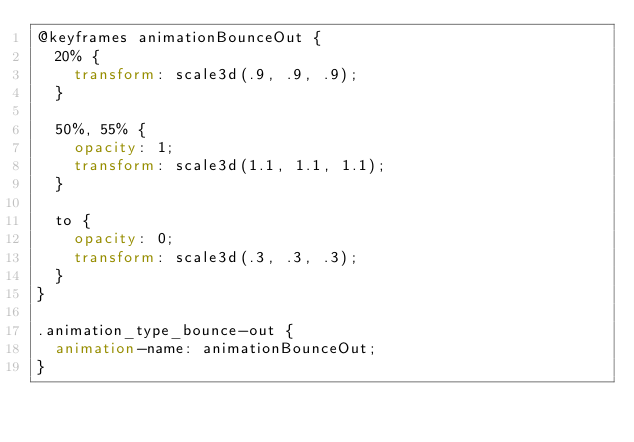Convert code to text. <code><loc_0><loc_0><loc_500><loc_500><_CSS_>@keyframes animationBounceOut {
  20% {
    transform: scale3d(.9, .9, .9);
  }
  
  50%, 55% {
    opacity: 1;
    transform: scale3d(1.1, 1.1, 1.1);
  }
  
  to {
    opacity: 0;
    transform: scale3d(.3, .3, .3);
  }
}

.animation_type_bounce-out {
  animation-name: animationBounceOut;
}
</code> 